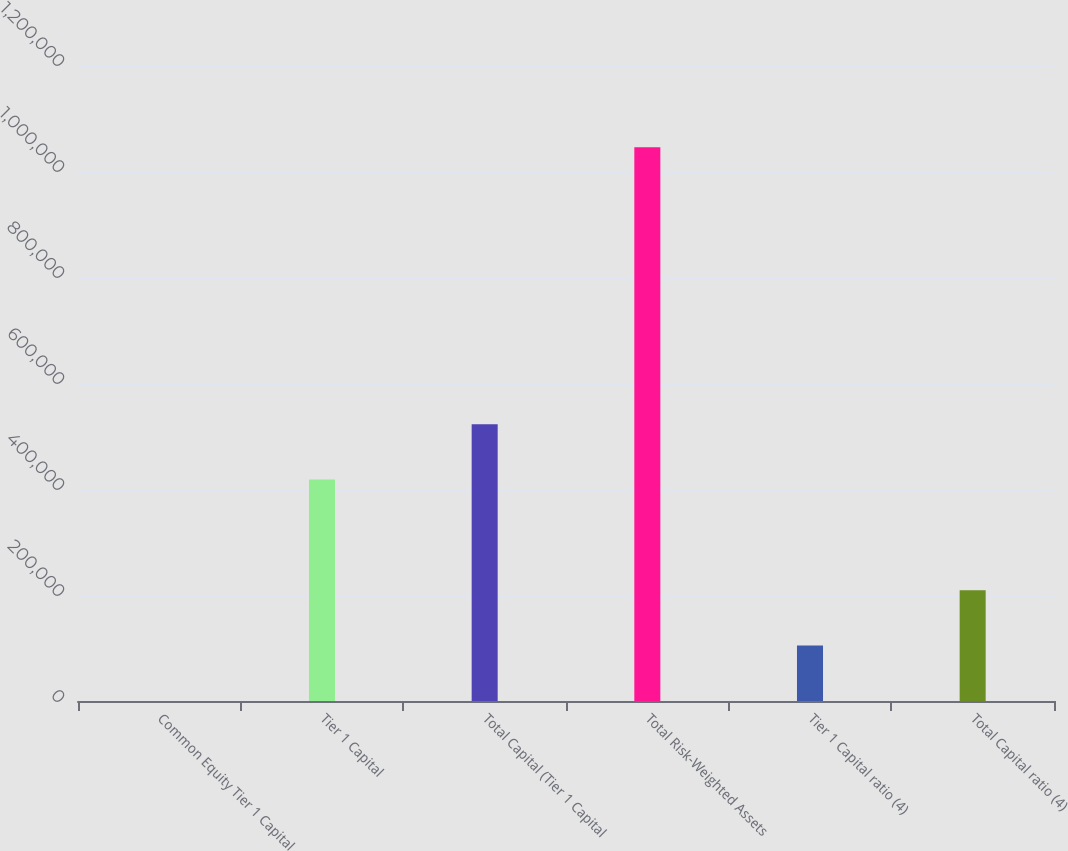Convert chart to OTSL. <chart><loc_0><loc_0><loc_500><loc_500><bar_chart><fcel>Common Equity Tier 1 Capital<fcel>Tier 1 Capital<fcel>Total Capital (Tier 1 Capital<fcel>Total Risk-Weighted Assets<fcel>Tier 1 Capital ratio (4)<fcel>Total Capital ratio (4)<nl><fcel>12.28<fcel>417915<fcel>522390<fcel>1.04477e+06<fcel>104488<fcel>208963<nl></chart> 